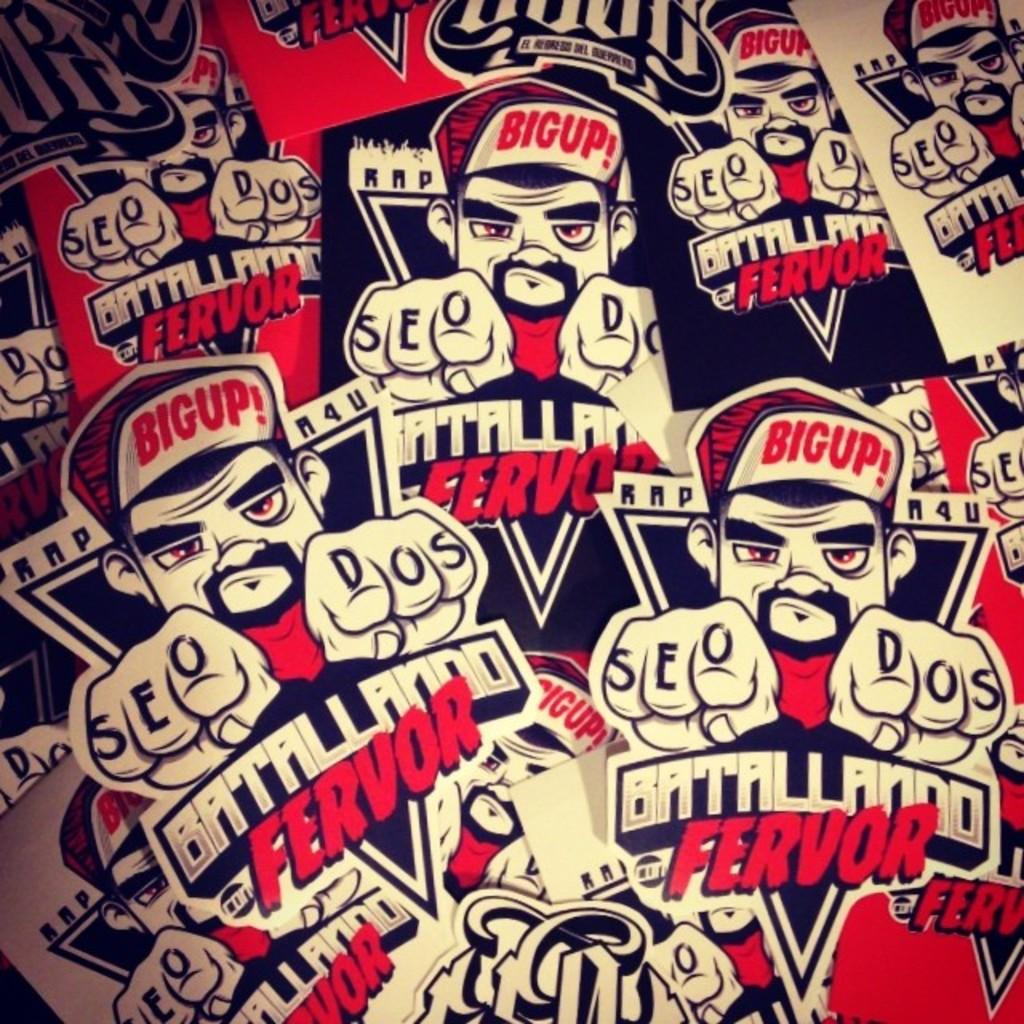<image>
Present a compact description of the photo's key features. A man with a cap that reads Big, with both index fingers pointed forward, appears repeatedly alongside words Battalliando Fervor 